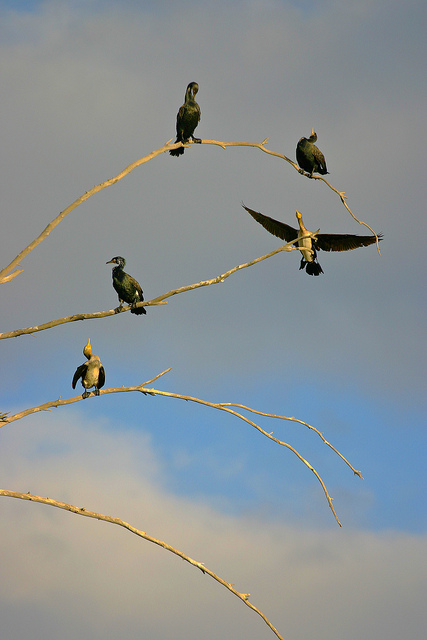Can these birds be found in urban areas? It is possible to observe such birds in urban settings, especially in parks or near waterways, as some species have adapted to human-altered landscapes. 